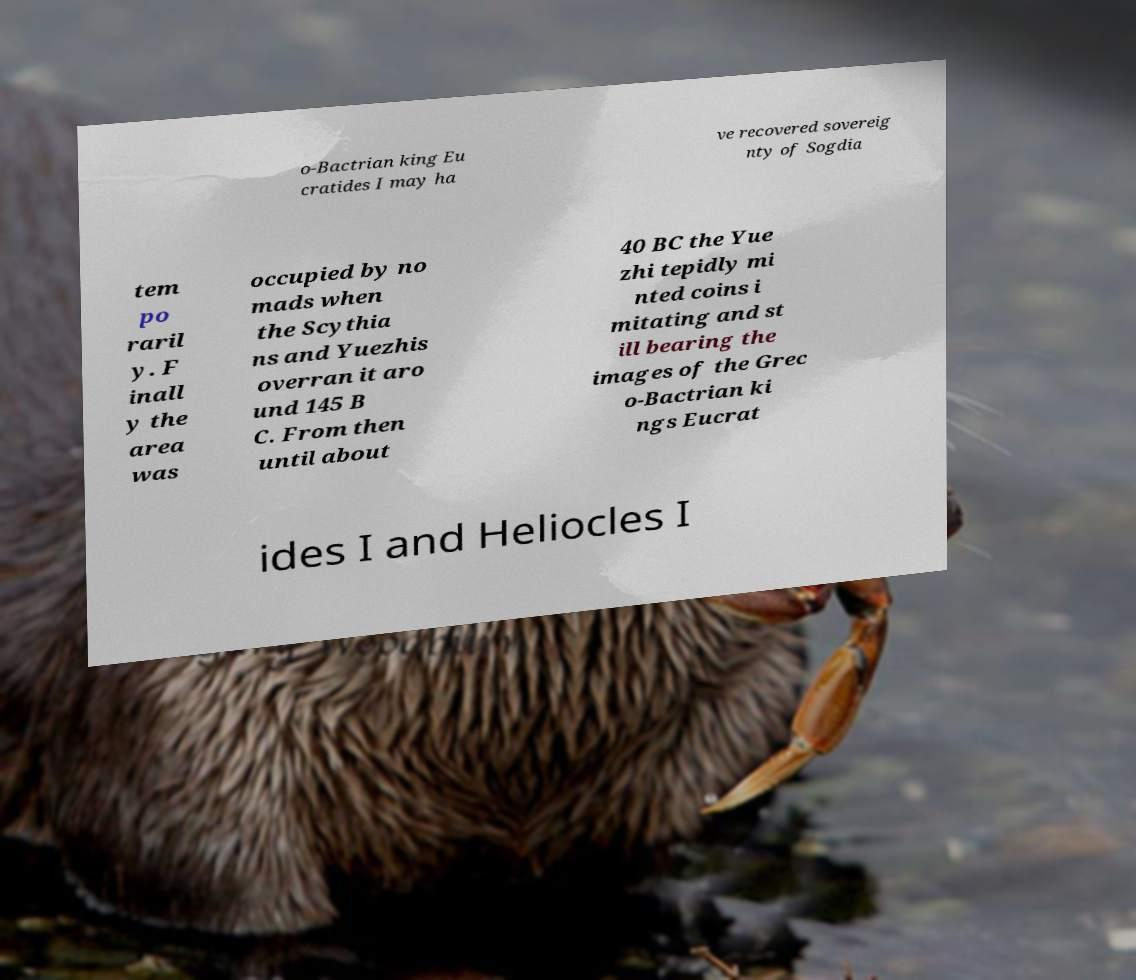Could you assist in decoding the text presented in this image and type it out clearly? o-Bactrian king Eu cratides I may ha ve recovered sovereig nty of Sogdia tem po raril y. F inall y the area was occupied by no mads when the Scythia ns and Yuezhis overran it aro und 145 B C. From then until about 40 BC the Yue zhi tepidly mi nted coins i mitating and st ill bearing the images of the Grec o-Bactrian ki ngs Eucrat ides I and Heliocles I 